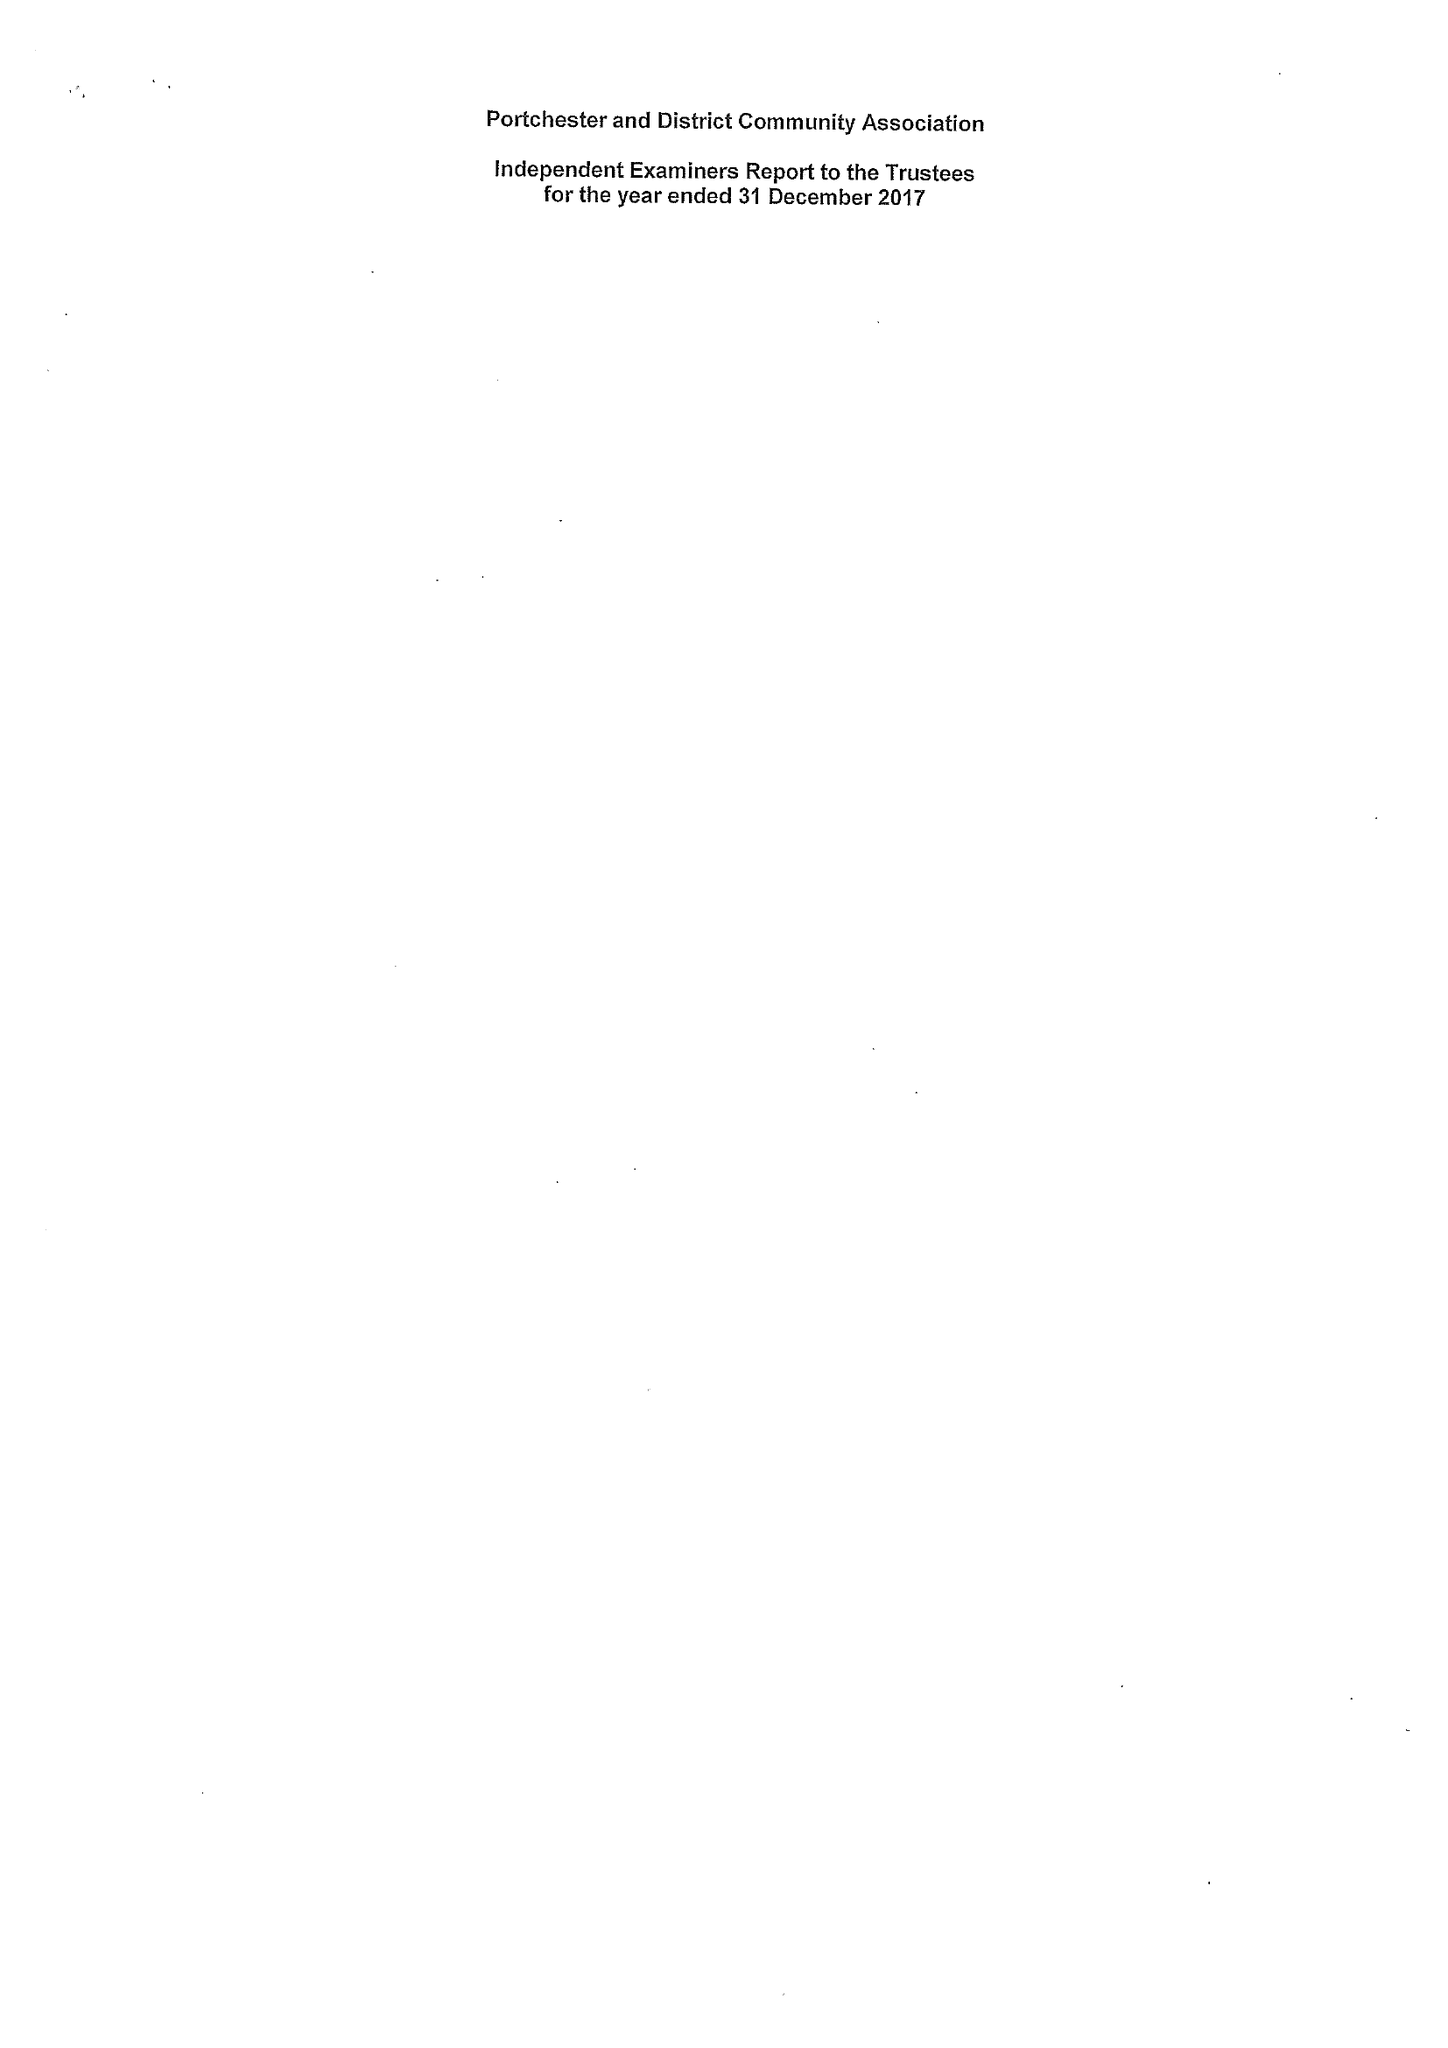What is the value for the address__post_town?
Answer the question using a single word or phrase. FAREHAM 